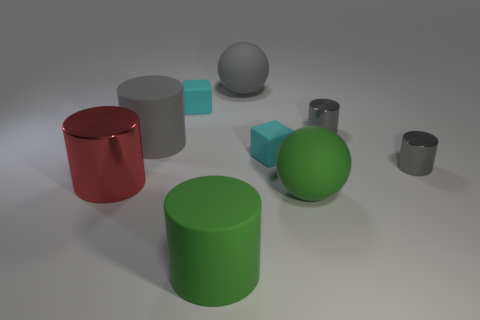Subtract all gray blocks. How many gray cylinders are left? 3 Subtract all large green rubber cylinders. How many cylinders are left? 4 Subtract all purple cylinders. Subtract all yellow balls. How many cylinders are left? 5 Add 1 big spheres. How many objects exist? 10 Subtract all balls. How many objects are left? 7 Add 4 cyan things. How many cyan things are left? 6 Add 9 red metal cylinders. How many red metal cylinders exist? 10 Subtract 1 green cylinders. How many objects are left? 8 Subtract all rubber balls. Subtract all rubber things. How many objects are left? 1 